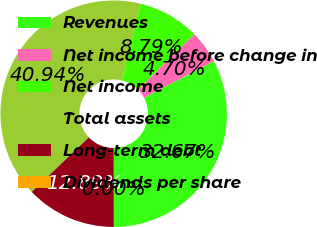Convert chart to OTSL. <chart><loc_0><loc_0><loc_500><loc_500><pie_chart><fcel>Revenues<fcel>Net income before change in<fcel>Net income<fcel>Total assets<fcel>Long-term debt<fcel>Dividends per share<nl><fcel>32.67%<fcel>4.7%<fcel>8.79%<fcel>40.94%<fcel>12.89%<fcel>0.0%<nl></chart> 